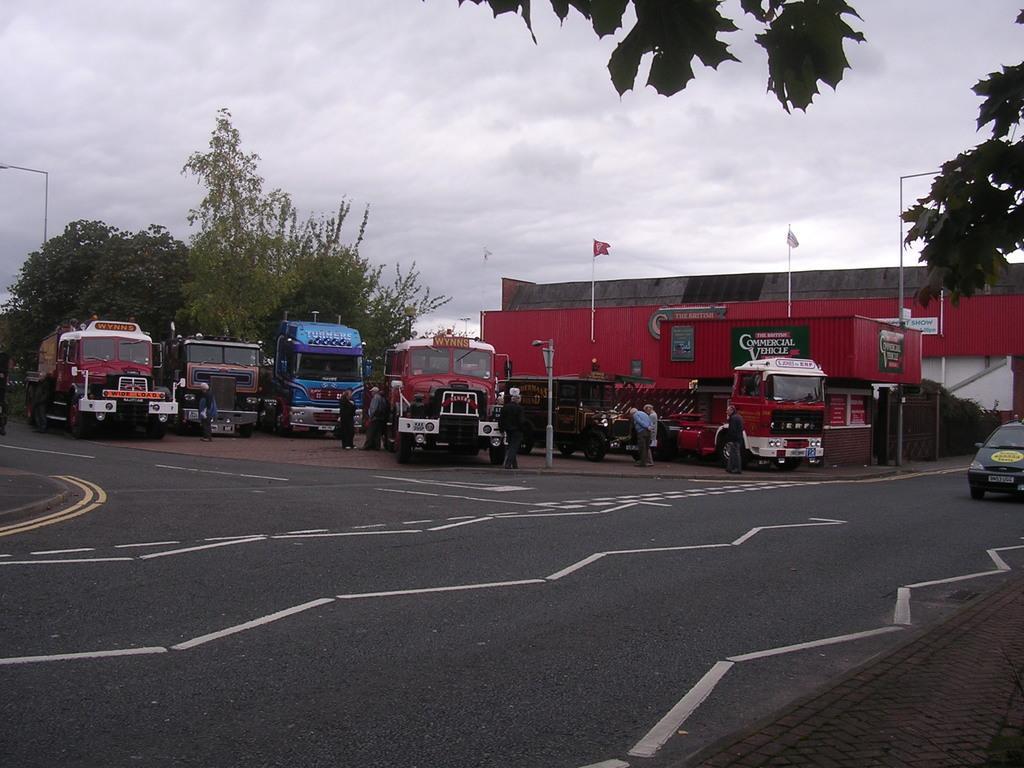Describe this image in one or two sentences. In this image I can see a vehicle on the road. In the background I can see many vehicles, few people, poles and the shed. I can see many trees and the sky. 